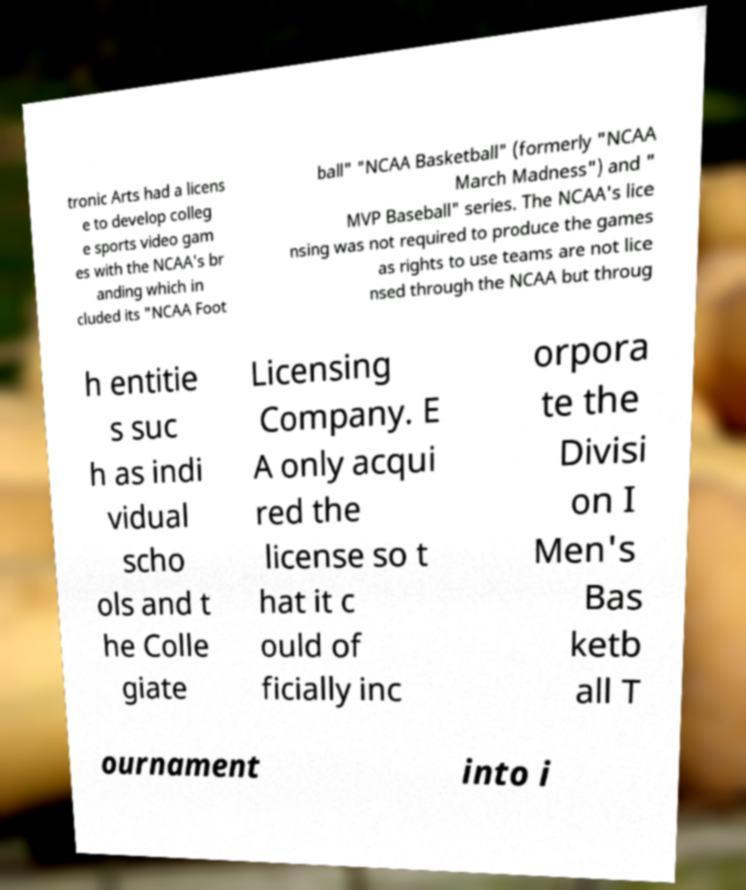For documentation purposes, I need the text within this image transcribed. Could you provide that? tronic Arts had a licens e to develop colleg e sports video gam es with the NCAA's br anding which in cluded its "NCAA Foot ball" "NCAA Basketball" (formerly "NCAA March Madness") and " MVP Baseball" series. The NCAA's lice nsing was not required to produce the games as rights to use teams are not lice nsed through the NCAA but throug h entitie s suc h as indi vidual scho ols and t he Colle giate Licensing Company. E A only acqui red the license so t hat it c ould of ficially inc orpora te the Divisi on I Men's Bas ketb all T ournament into i 